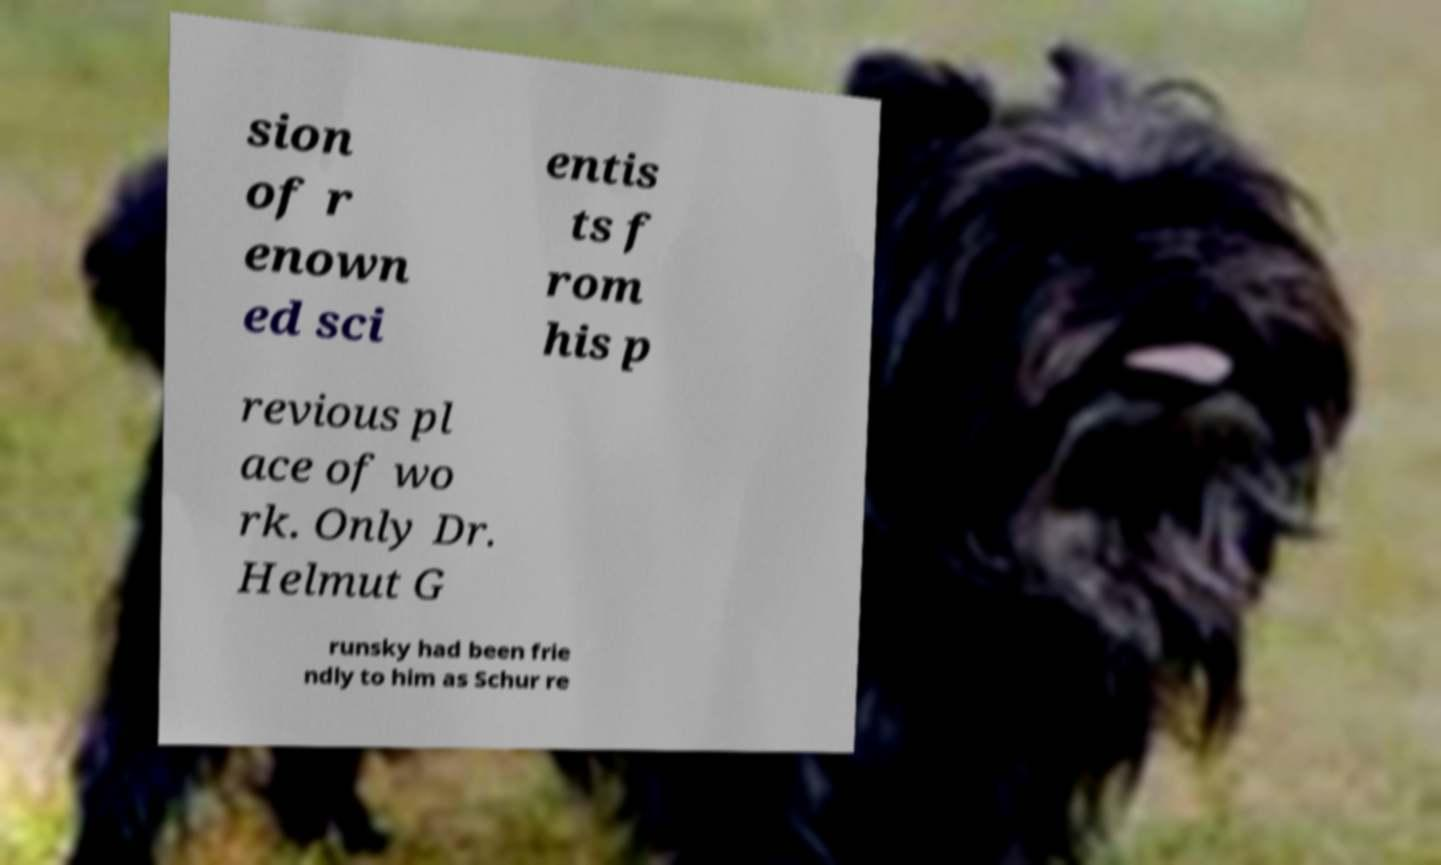Please read and relay the text visible in this image. What does it say? sion of r enown ed sci entis ts f rom his p revious pl ace of wo rk. Only Dr. Helmut G runsky had been frie ndly to him as Schur re 